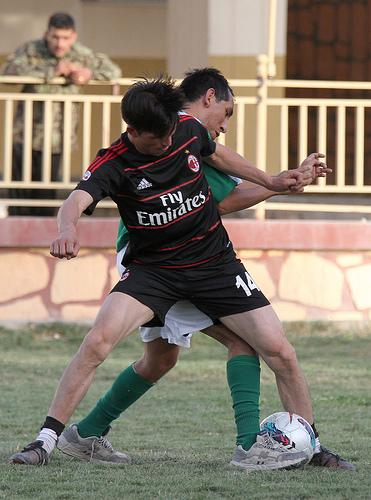Can you identify any particular emotion or sentiment portrayed in the image? The image portrays a sense of competitiveness and determination as the soccer players fight for the ball. Provide a detailed description of the soccer ball in the image. The soccer ball is round and on the ground, being kicked by one of the soccer players. Describe the scene surrounding the two soccer players. There is a person leaning on a yellow metal railing observing the game, and the large stones on the wall are also visible in the background. Identify the primary activity taking place in the image. Two men are playing soccer and fighting for the ball. What type of socks are the soccer players wearing? One player is wearing tall green socks, and the other is wearing white and black socks. What are some notable features of the man observing the game? The man observing the game is wearing a camouflage jacket and leaning over the yellow metal railing. What type of clothing is one of the soccer players wearing? One of the soccer players is wearing a black and red soccer uniform with the number 14 on his shorts. How many people are visible in the image and what are they doing? Three people are visible. Two men are playing soccer, and another person is observing the game while leaning on a railing. Describe one of the soccer player's shirt and any logo or writing found on it. One soccer player is wearing a black shirt with red lines, the Adidas logo, and the logo of the soccer team. Explain the kind of sneakers visible in the image and any specific features. There are gray sneakers visible, including one untied shoe and a New Balance brand shoe. 